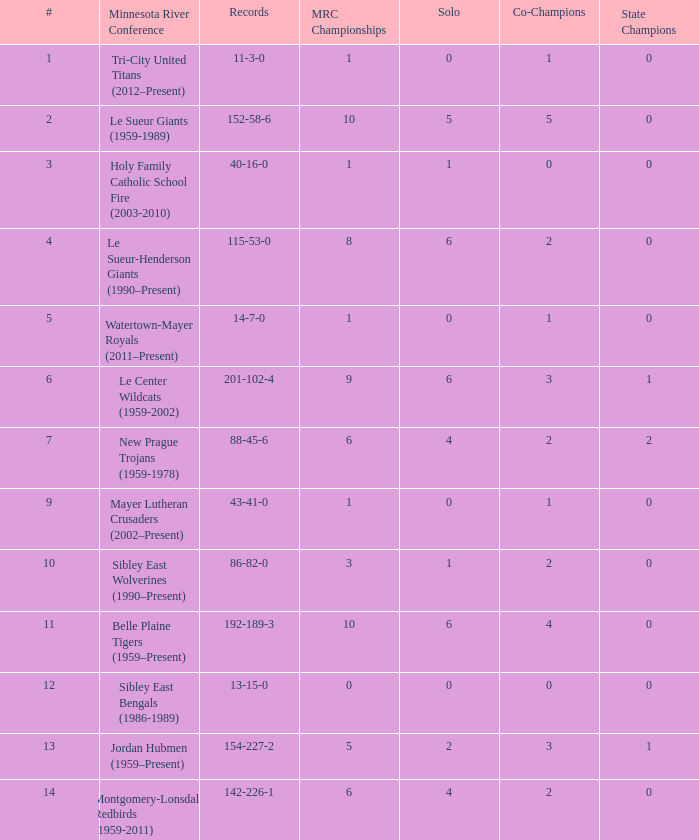What are the record(s) for the team with a winning percentage of .464? 13-15-0. 